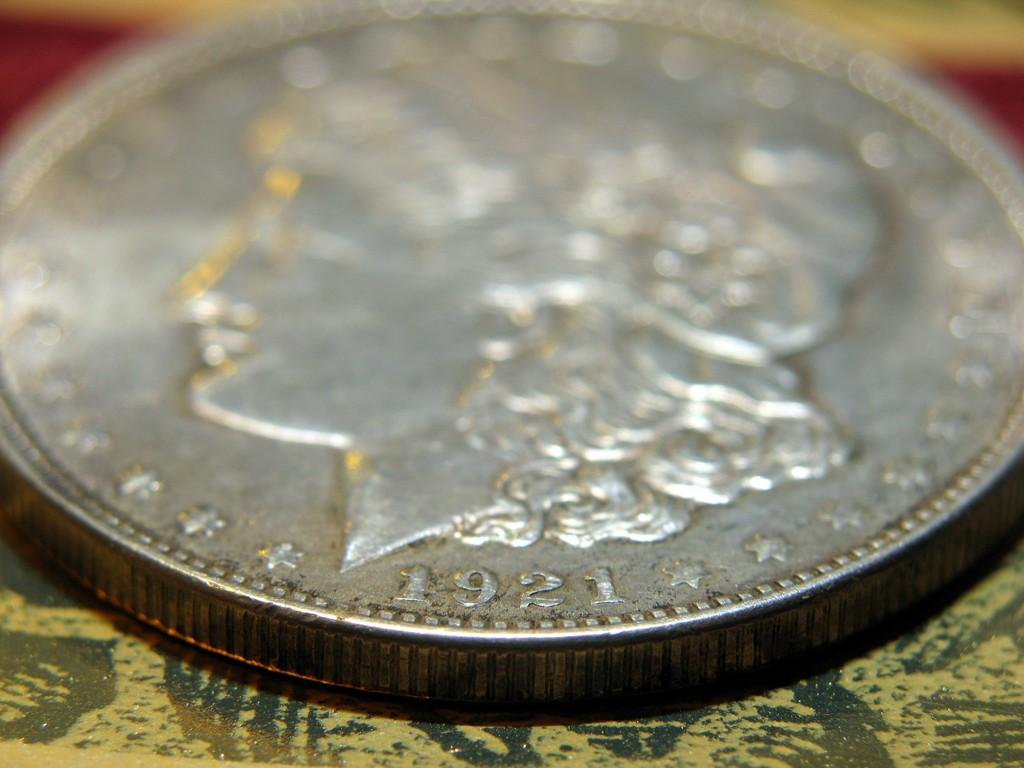<image>
Render a clear and concise summary of the photo. a close up of a silver coin minted in 1921 